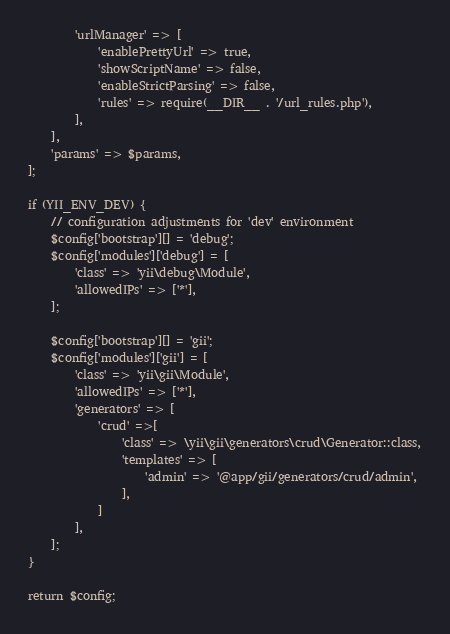Convert code to text. <code><loc_0><loc_0><loc_500><loc_500><_PHP_>        'urlManager' => [
            'enablePrettyUrl' => true,
            'showScriptName' => false,
            'enableStrictParsing' => false,
            'rules' => require(__DIR__ . '/url_rules.php'),
        ],
    ],
    'params' => $params,
];

if (YII_ENV_DEV) {
    // configuration adjustments for 'dev' environment
    $config['bootstrap'][] = 'debug';
    $config['modules']['debug'] = [
        'class' => 'yii\debug\Module',
        'allowedIPs' => ['*'],
    ];

    $config['bootstrap'][] = 'gii';
    $config['modules']['gii'] = [
        'class' => 'yii\gii\Module',
        'allowedIPs' => ['*'],
        'generators' => [
            'crud' =>[
                'class' => \yii\gii\generators\crud\Generator::class,
                'templates' => [
                    'admin' => '@app/gii/generators/crud/admin',
                ],
            ]
        ],
    ];
}

return $config;
</code> 